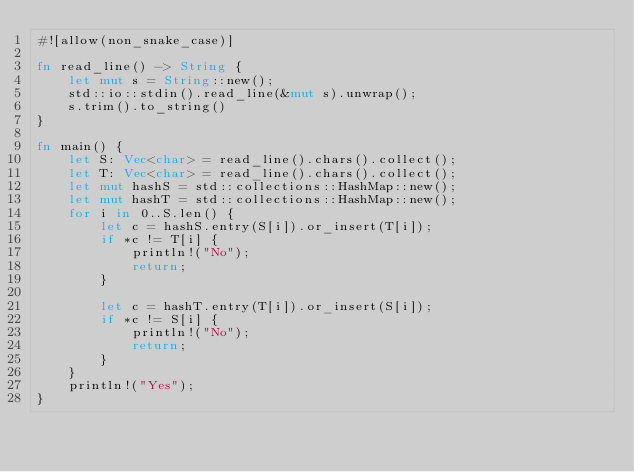<code> <loc_0><loc_0><loc_500><loc_500><_Rust_>#![allow(non_snake_case)]

fn read_line() -> String {
    let mut s = String::new();
    std::io::stdin().read_line(&mut s).unwrap();
    s.trim().to_string()
}

fn main() {
    let S: Vec<char> = read_line().chars().collect();
    let T: Vec<char> = read_line().chars().collect();
    let mut hashS = std::collections::HashMap::new();
    let mut hashT = std::collections::HashMap::new();
    for i in 0..S.len() {
        let c = hashS.entry(S[i]).or_insert(T[i]);
        if *c != T[i] {
            println!("No");
            return;
        }
        
        let c = hashT.entry(T[i]).or_insert(S[i]);
        if *c != S[i] {
            println!("No");
            return;
        }
    }
    println!("Yes");
}
</code> 